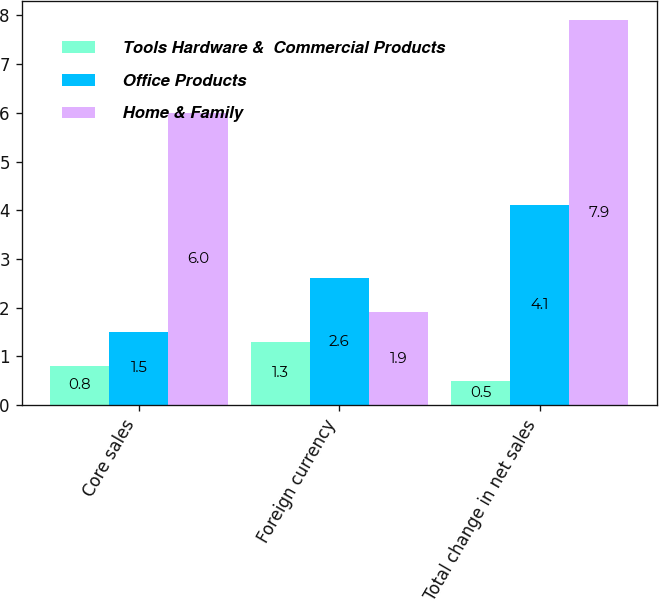Convert chart to OTSL. <chart><loc_0><loc_0><loc_500><loc_500><stacked_bar_chart><ecel><fcel>Core sales<fcel>Foreign currency<fcel>Total change in net sales<nl><fcel>Tools Hardware &  Commercial Products<fcel>0.8<fcel>1.3<fcel>0.5<nl><fcel>Office Products<fcel>1.5<fcel>2.6<fcel>4.1<nl><fcel>Home & Family<fcel>6<fcel>1.9<fcel>7.9<nl></chart> 